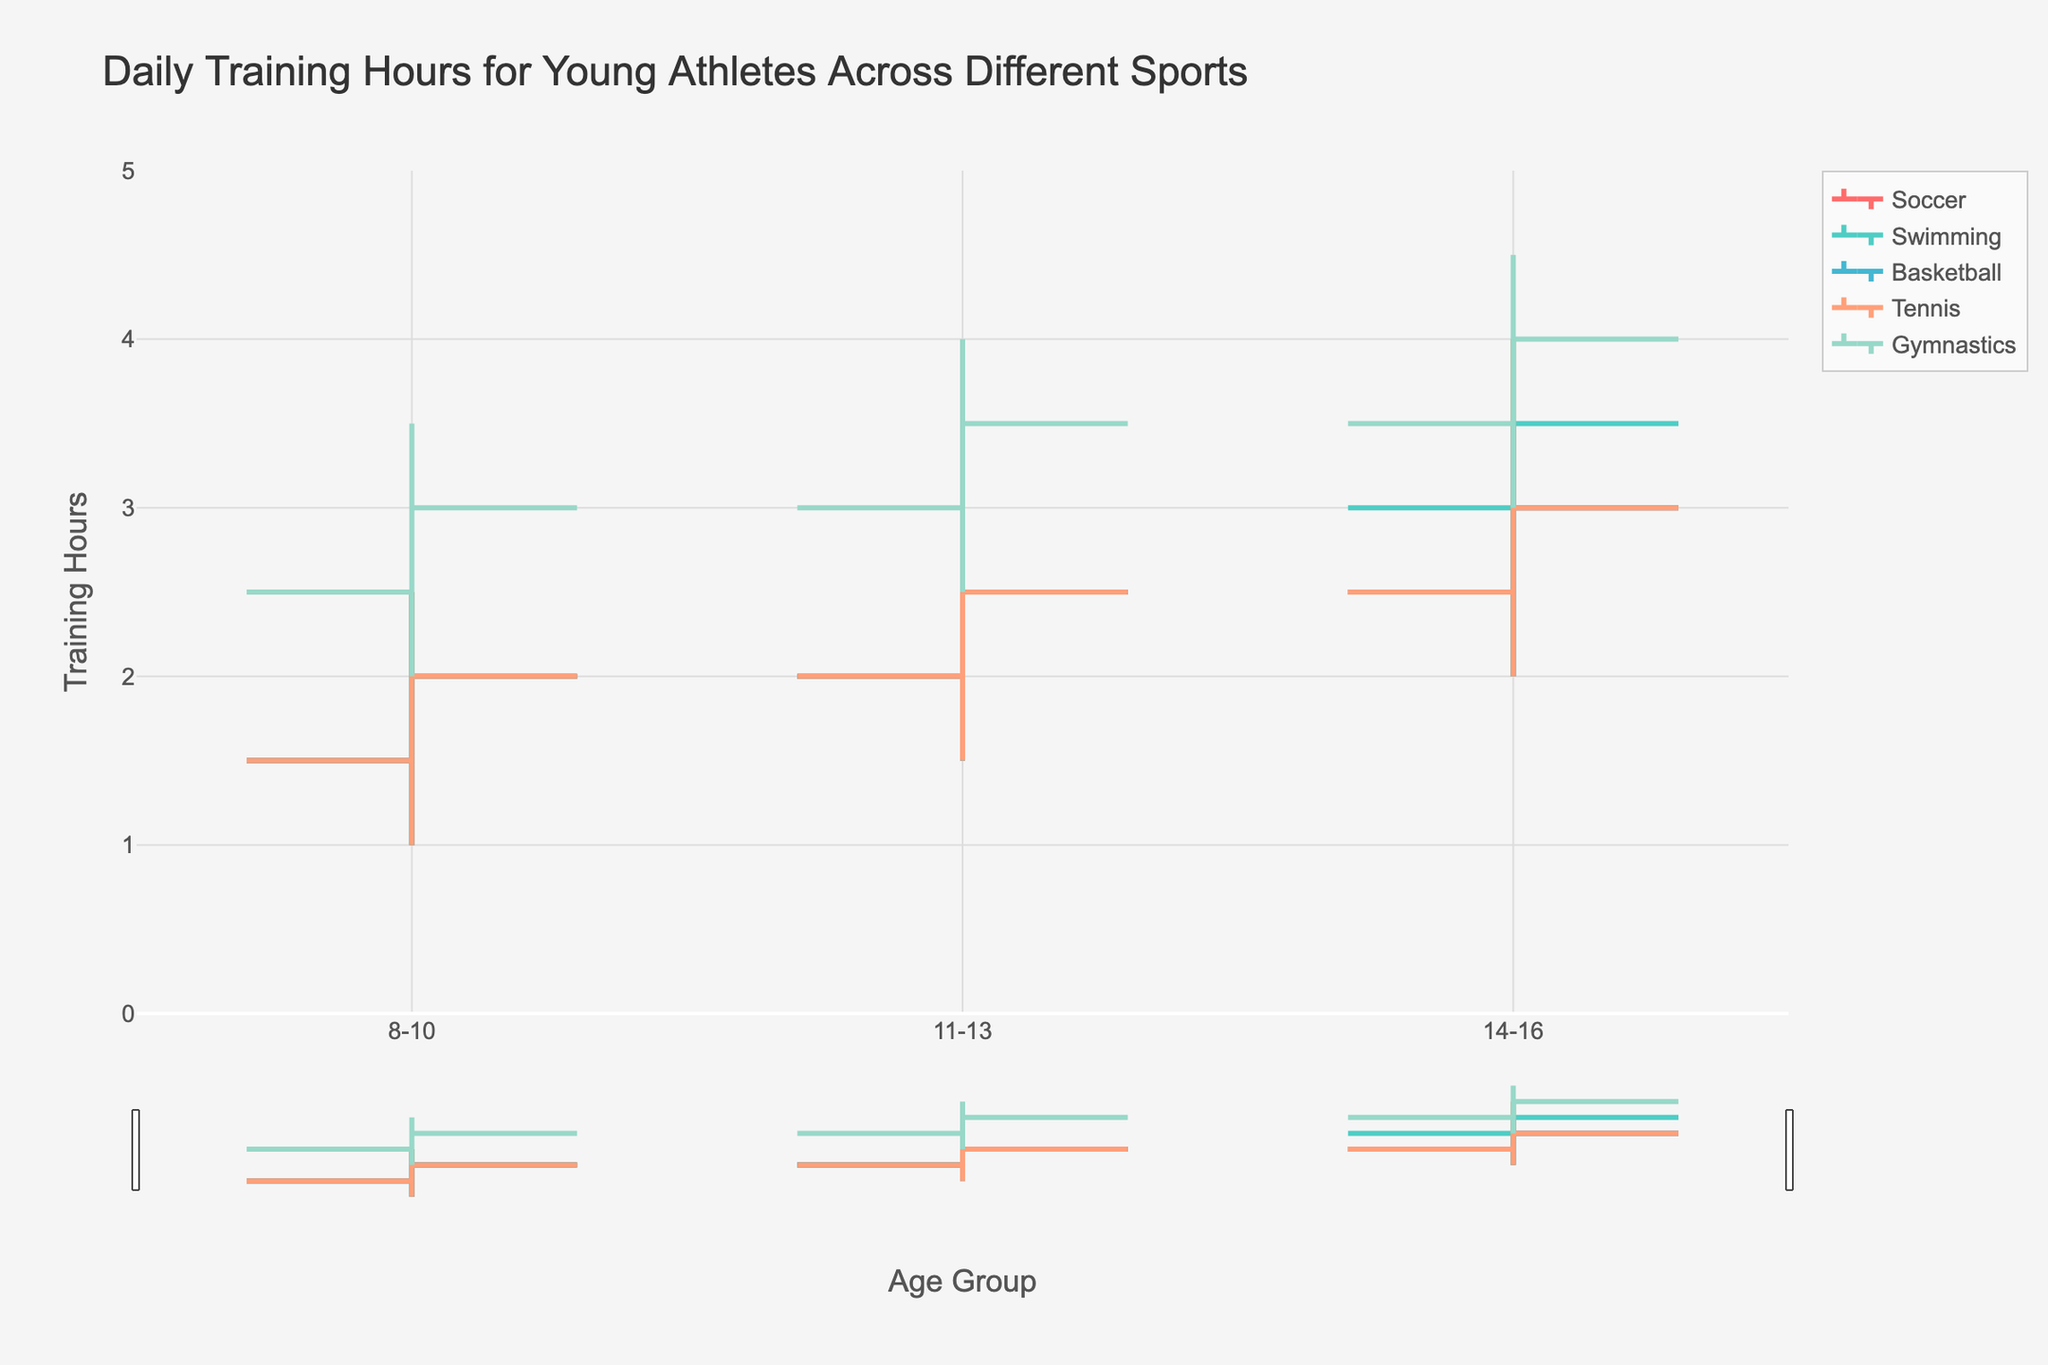What is the title of the figure? The title is usually prominently displayed at the top of the figure. In this chart, it is "Daily Training Hours for Young Athletes Across Different Sports".
Answer: Daily Training Hours for Young Athletes Across Different Sports What are the age groups represented on the x-axis? The x-axis labels indicate the age groups which are "8-10", "11-13", and "14-16".
Answer: 8-10, 11-13, 14-16 Which sport has the highest maximum training hours for the age group 14-16? By looking at the highest value among the age group 14-16 across all sports, it's apparent that Swimming and Gymnastics both reach a high of 4.0 and 4.5 training hours respectively.
Answer: Gymnastics How does the range of training hours in Tennis for age group 14-16 compare to age group 8-10? For Tennis, the high-low range can be calculated for each age group. For 14-16, it ranges from 2.0 to 4.0 (2 hours). For 8-10, it ranges from 1.0 to 2.5 (1.5 hours). So, the range increases as age increases.
Answer: 2 hours vs. 1.5 hours Which sport shows the most consistent training hours across all age groups? Gymnastics has the smallest increment in low, open, close, and high hours across age groups, suggesting higher consistency. The other sports show more dramatic increments.
Answer: Gymnastics What is the average close value for Soccer across all age groups? Summing the close values for each age group in Soccer (2.0 + 2.5 + 3.0) and then dividing by the number of age groups (3), yields the average close value, which is 2.5.
Answer: 2.5 Which sport has the lowest minimum training hours across all age groups and what is the value? By observing the ‘Low’ column across all sports and age groups, it is evident that Soccer, Swimming, Basketball, and Tennis all have the lowest minimum training hours of 1.0.
Answer: Soccer, Swimming, Basketball, Tennis (all 1.0) Does Swimming show an increase in training hours with age? Reviewing the data for Swimming, we see that all the open, close, low, and high values increase as the age group increases from 8-10 to 14-16.
Answer: Yes Which age group in Gymnastics has the highest close value and what is it? Looking at the close values for Gymnastics across the age groups, we see that the 14-16 age group has the highest close value of 4.0.
Answer: 14-16, 4.0 